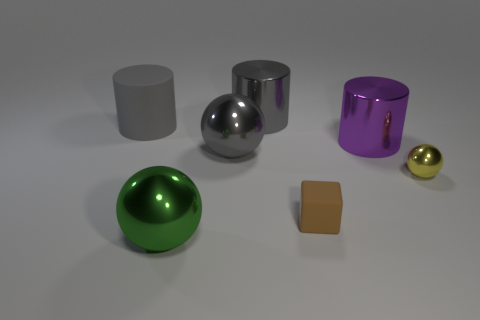Can you describe the shapes and colors of the objects in this image? Certainly! The image displays a collection of geometric objects, each with a distinct shape and color. In the foreground, we have a green sphere with a reflective surface. There's a matte-finish brown cube and a small, glossy gold sphere. Towards the middle, a large, reflective gray sphere takes center stage, alongside a reflective silver cylinder. Finally, there's a purple, translucent cylinder with a bit of reflection on its right side. The background is a neutral gray, which enhances the visibility of these objects. 